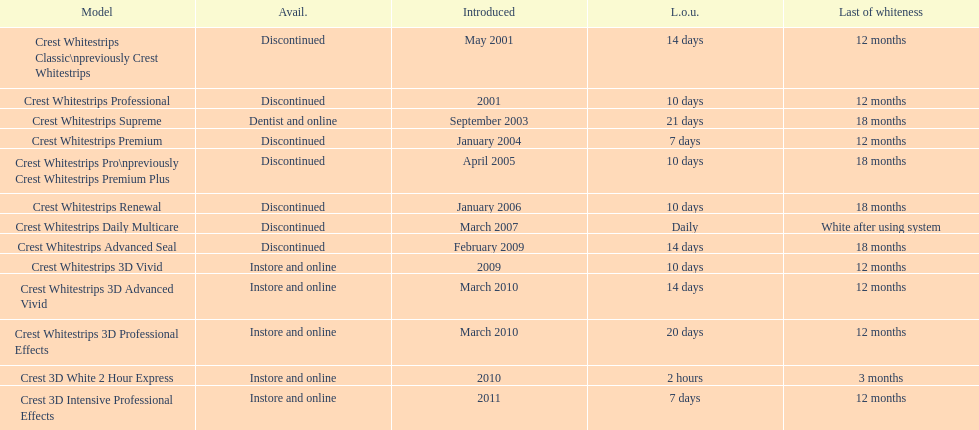How many models require less than a week of use? 2. 